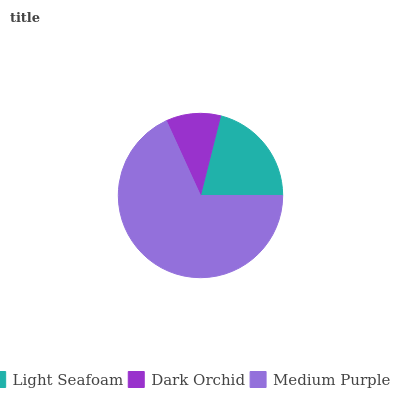Is Dark Orchid the minimum?
Answer yes or no. Yes. Is Medium Purple the maximum?
Answer yes or no. Yes. Is Medium Purple the minimum?
Answer yes or no. No. Is Dark Orchid the maximum?
Answer yes or no. No. Is Medium Purple greater than Dark Orchid?
Answer yes or no. Yes. Is Dark Orchid less than Medium Purple?
Answer yes or no. Yes. Is Dark Orchid greater than Medium Purple?
Answer yes or no. No. Is Medium Purple less than Dark Orchid?
Answer yes or no. No. Is Light Seafoam the high median?
Answer yes or no. Yes. Is Light Seafoam the low median?
Answer yes or no. Yes. Is Dark Orchid the high median?
Answer yes or no. No. Is Dark Orchid the low median?
Answer yes or no. No. 